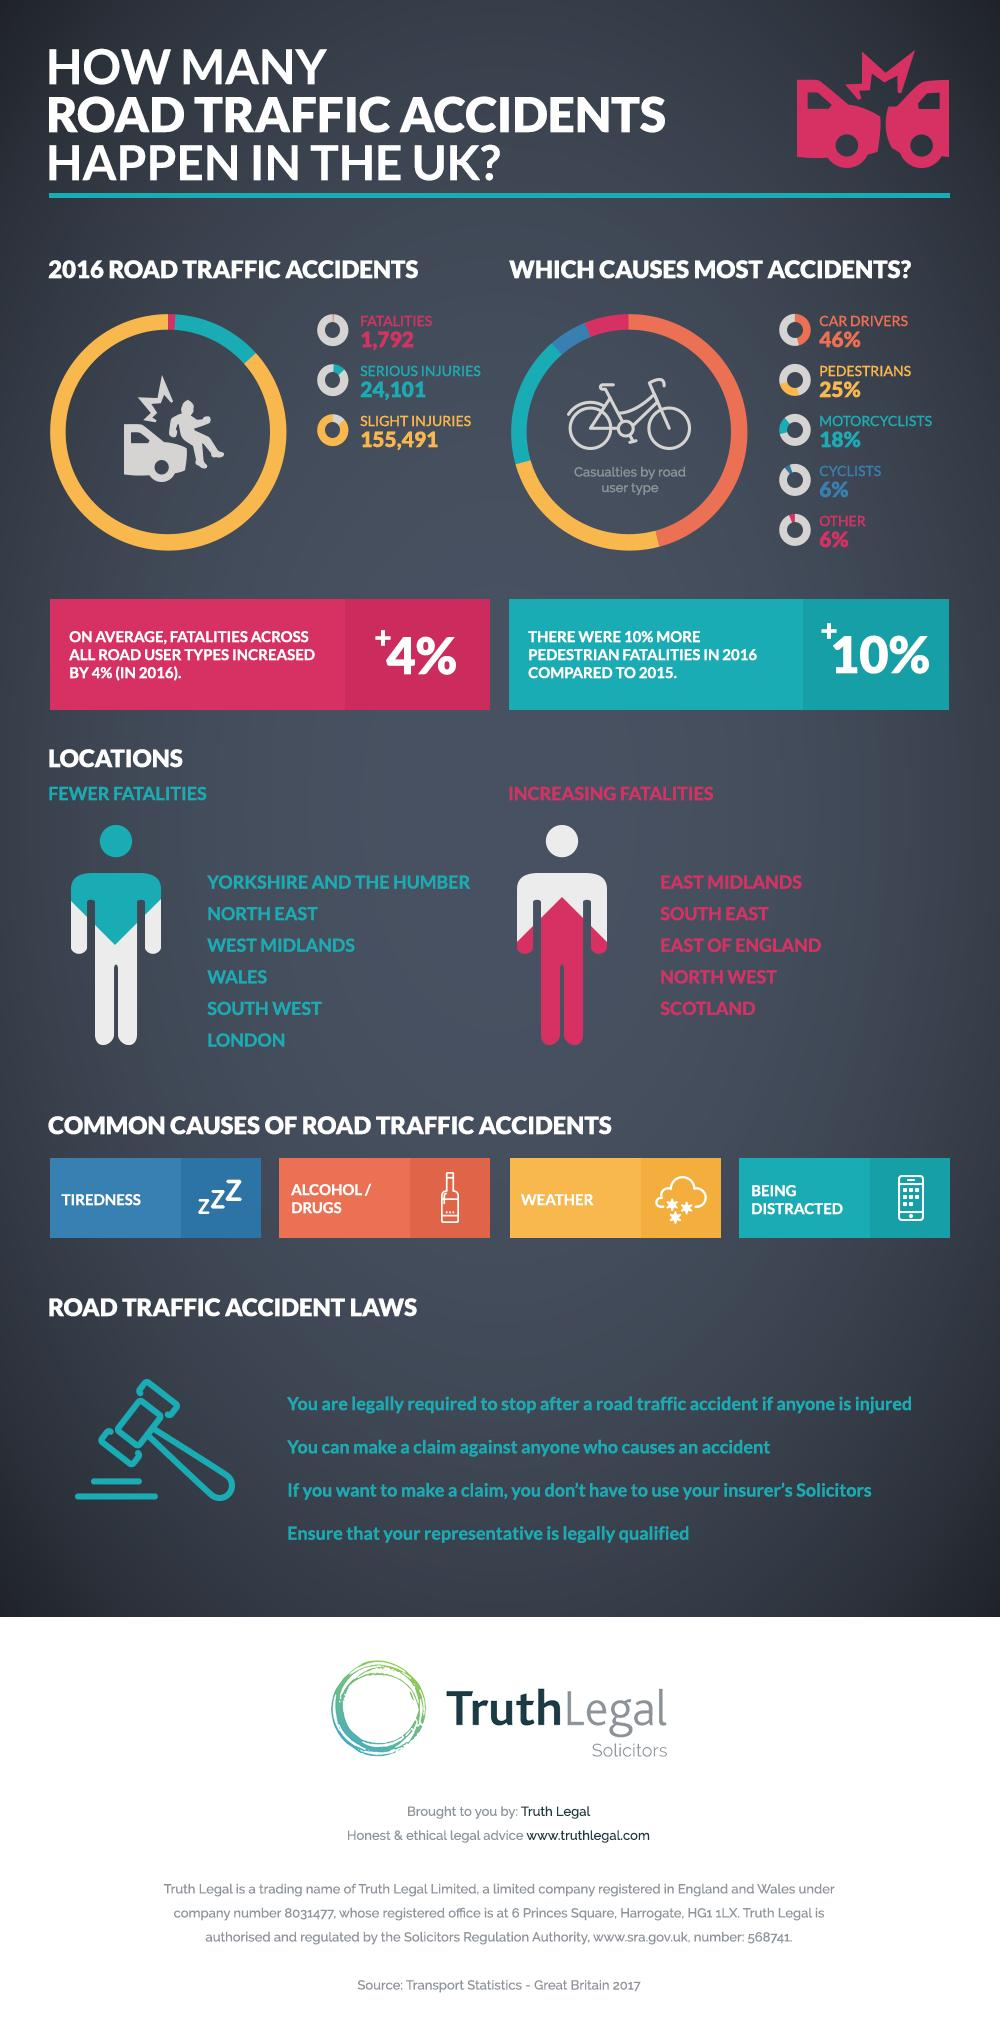Draw attention to some important aspects in this diagram. The North East region experienced the fewest fatalities out of the three regions mentioned. In 2016, there was an increase of 10% in pedestrian fatalities. The second most common cause of road accidents is alcohol and drugs. In the year 2016, a total of 1,792 fatalities were reported as a result of road accidents. The average increase in fatalities due to road accidents was 4%. 